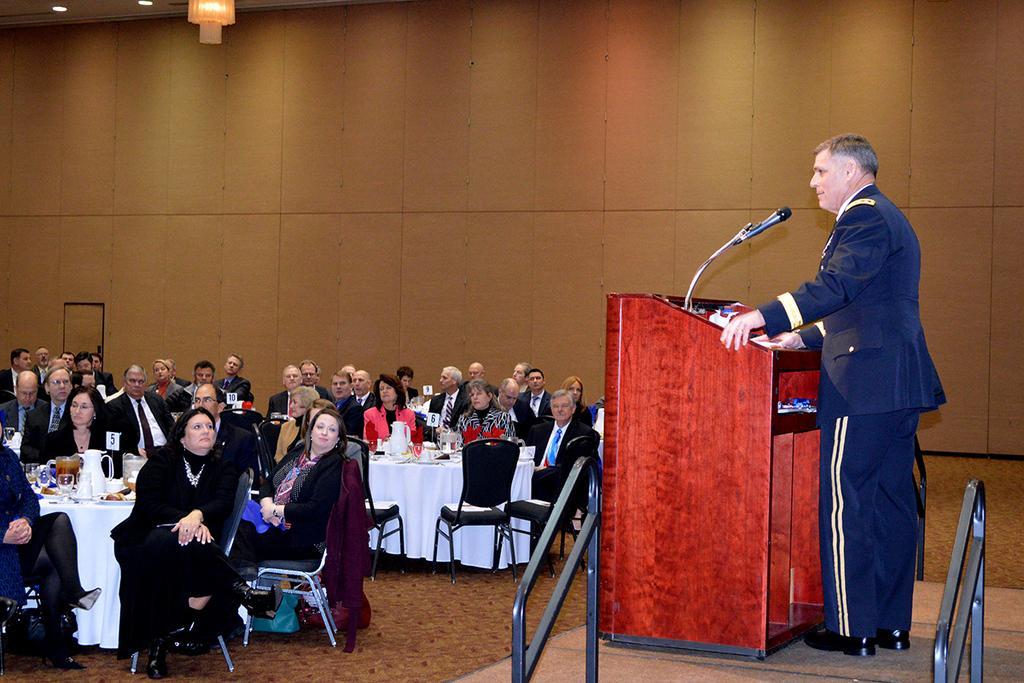Can you describe this image briefly? This picture is clicked in a restaurant. In this, picture we see many people sitting on chair. On the right corner of the picture, we see man in blue blazer is standing near the podium, is talking something on microphone. In front of the picture, we see table with white cloth on which we see many jar, bottle, glass and some plates on it. Behind these people, we see a wall and on top of the picture, we see light. 